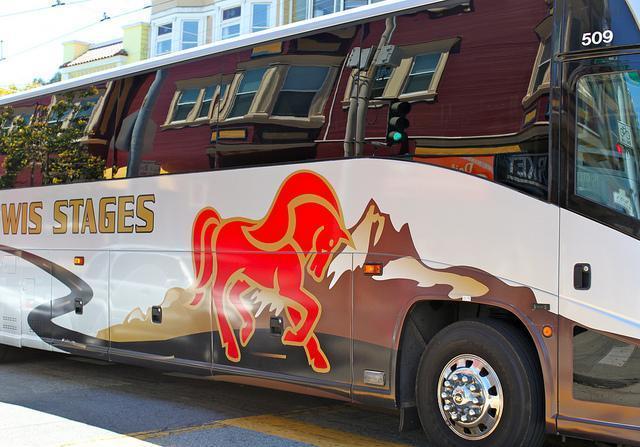Is the given caption "The horse is part of the bus." fitting for the image?
Answer yes or no. Yes. Does the caption "The horse is on the bus." correctly depict the image?
Answer yes or no. Yes. 